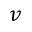<formula> <loc_0><loc_0><loc_500><loc_500>v</formula> 